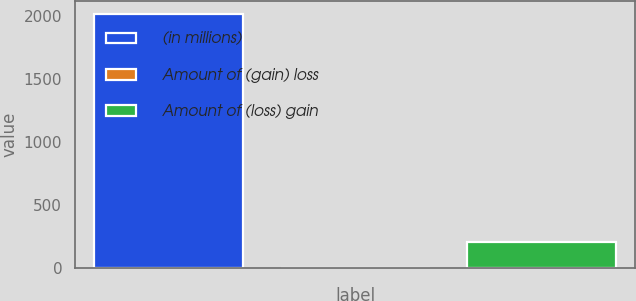Convert chart to OTSL. <chart><loc_0><loc_0><loc_500><loc_500><bar_chart><fcel>(in millions)<fcel>Amount of (gain) loss<fcel>Amount of (loss) gain<nl><fcel>2016<fcel>2<fcel>203.4<nl></chart> 